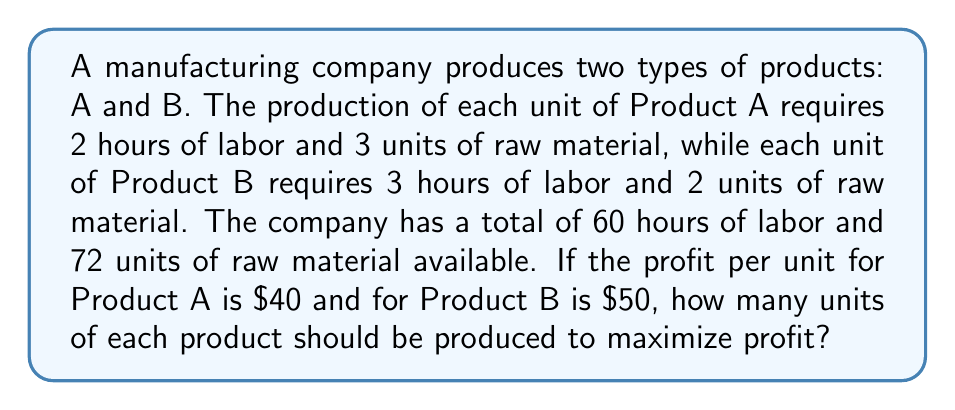What is the answer to this math problem? Let's approach this step-by-step:

1) Define variables:
   Let $x$ = number of units of Product A
   Let $y$ = number of units of Product B

2) Set up constraints:
   Labor constraint: $2x + 3y \leq 60$
   Raw material constraint: $3x + 2y \leq 72$
   Non-negativity constraints: $x \geq 0$, $y \geq 0$

3) Set up the objective function:
   Profit = $40x + 50y$

4) To solve this system, we'll use the corner point method. Find the corner points by solving the equations:

   a) $2x + 3y = 60$ and $3x + 2y = 72$
      Multiply the first equation by 3 and the second by 2:
      $6x + 9y = 180$
      $6x + 4y = 144$
      Subtracting: $5y = 36$
      $y = 7.2$
      Substituting back: $x = 12$

   b) $x = 0$ and $3y = 60$, so $y = 20$
   
   c) $y = 0$ and $3x = 72$, so $x = 24$

   d) $x = 0$ and $y = 0$

5) Evaluate the profit at each corner point:
   (12, 7.2): $40(12) + 50(7.2) = 840$
   (0, 20): $40(0) + 50(20) = 1000$
   (24, 0): $40(24) + 50(0) = 960$
   (0, 0): $40(0) + 50(0) = 0$

6) The maximum profit occurs at (0, 20), which means producing 0 units of Product A and 20 units of Product B.
Answer: 0 units of Product A, 20 units of Product B 